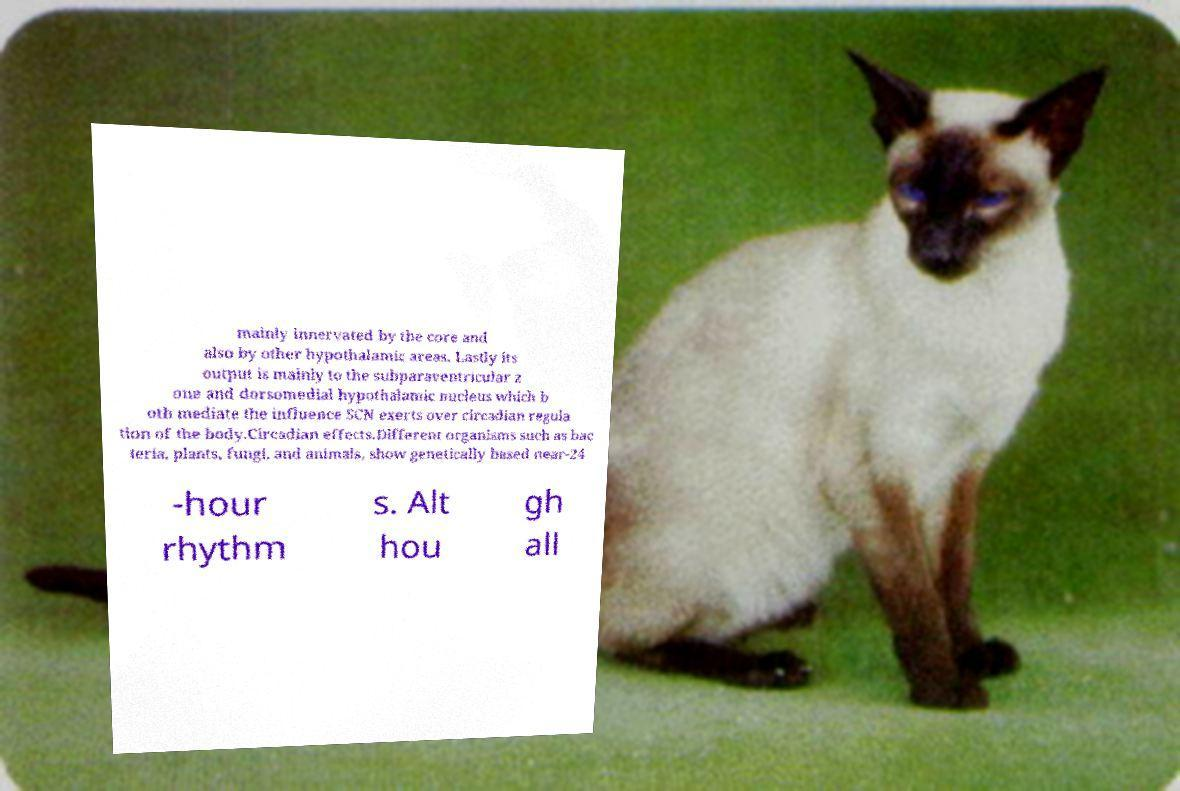Please identify and transcribe the text found in this image. mainly innervated by the core and also by other hypothalamic areas. Lastly its output is mainly to the subparaventricular z one and dorsomedial hypothalamic nucleus which b oth mediate the influence SCN exerts over circadian regula tion of the body.Circadian effects.Different organisms such as bac teria, plants, fungi, and animals, show genetically based near-24 -hour rhythm s. Alt hou gh all 